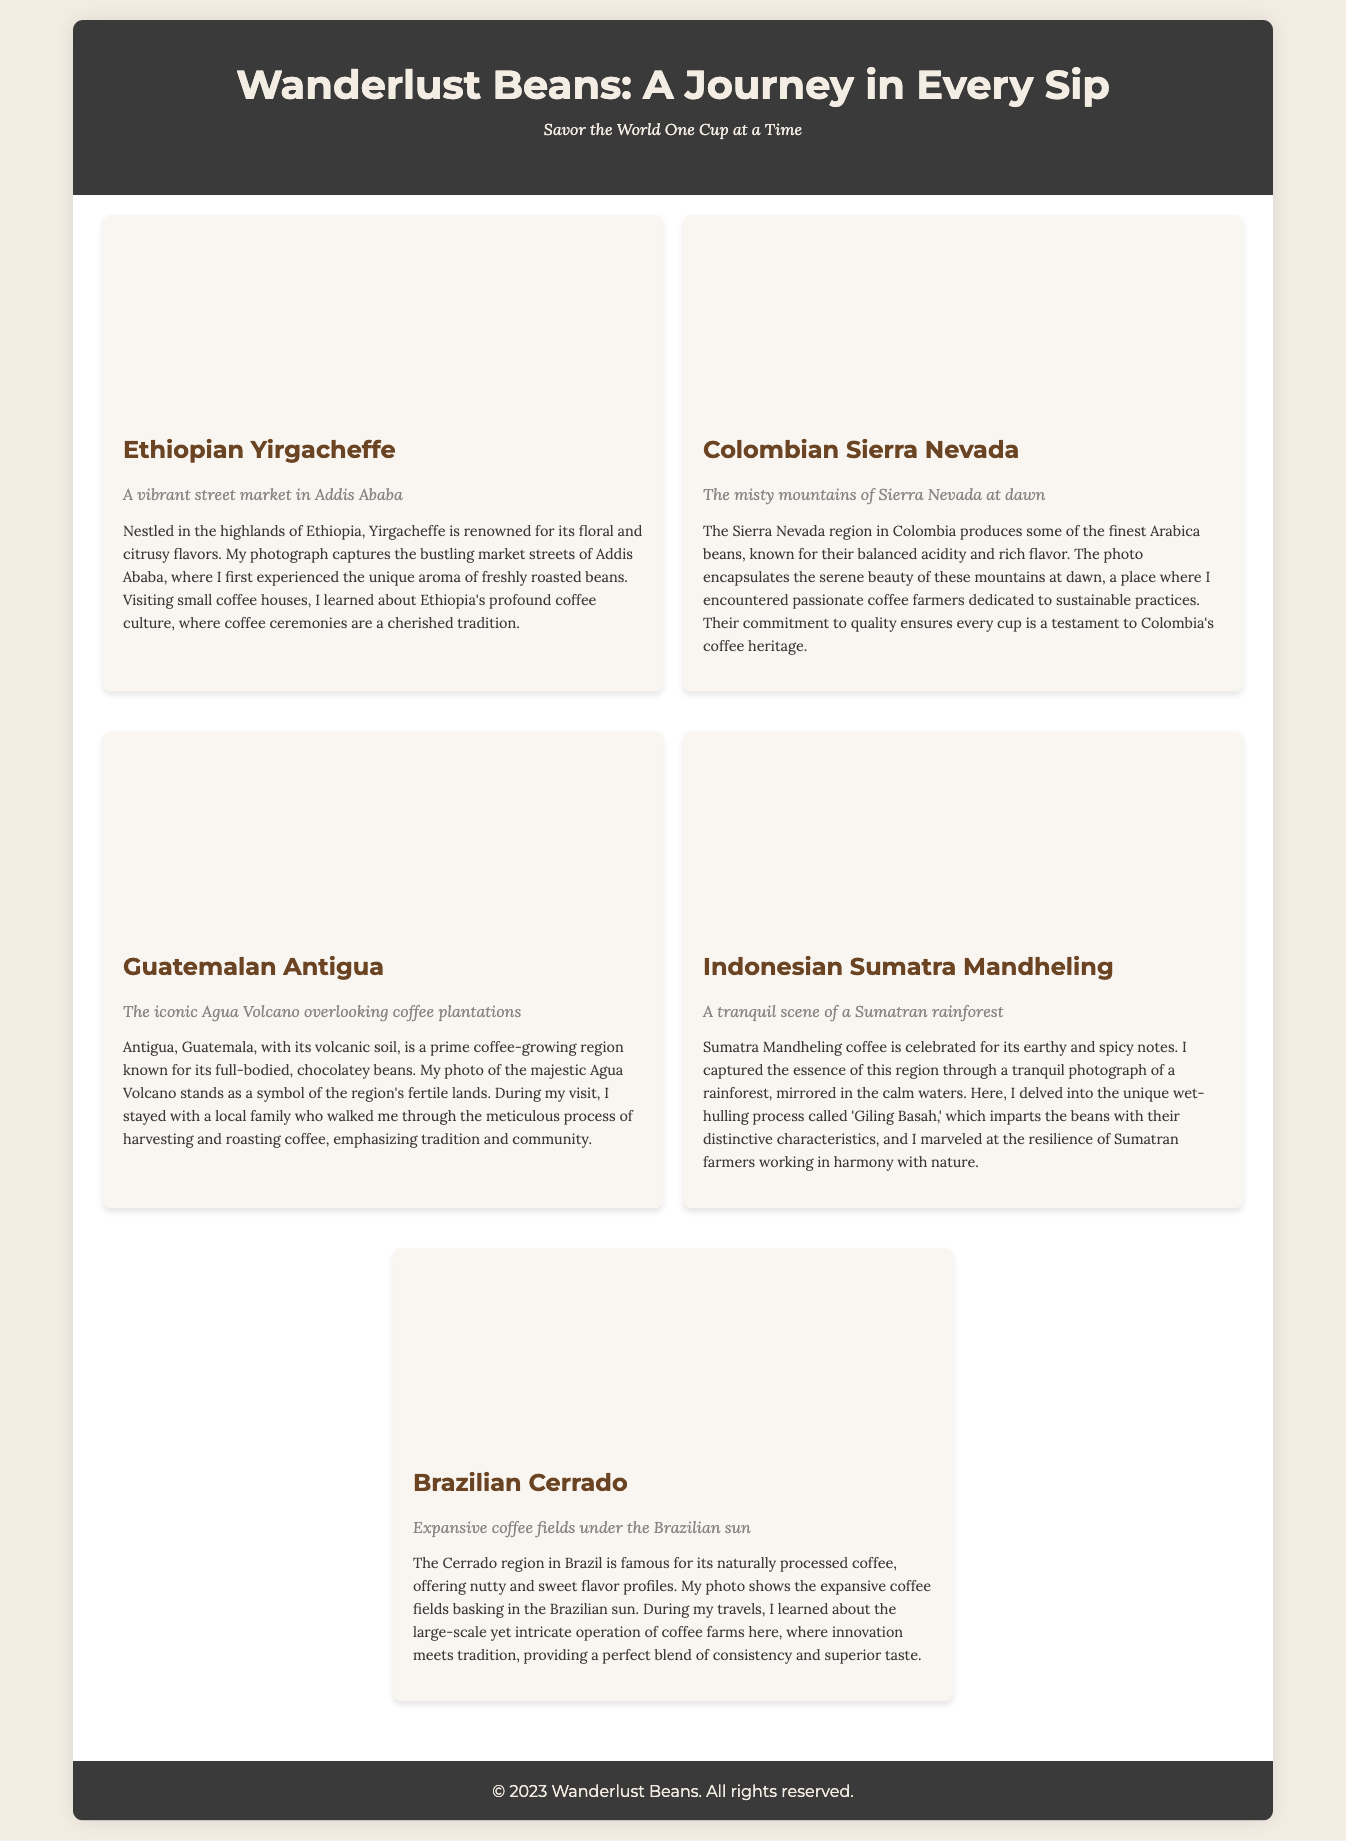What is the title of the collection? The title is prominently displayed at the top of the document and is "Wanderlust Beans: A Journey in Every Sip."
Answer: Wanderlust Beans: A Journey in Every Sip How many coffee types are featured? The document lists five distinct coffee types, each with its own story and image.
Answer: Five Which country is associated with Yirgacheffe coffee? The information provided in the document specifies Yirgacheffe coffee is from Ethiopia.
Answer: Ethiopia What flavor notes are described for the Colombian Sierra Nevada? The document describes the flavor notes of the Colombian Sierra Nevada coffee as "balanced acidity and rich flavor."
Answer: Balanced acidity and rich flavor What process infuses unique characteristics into Sumatran coffee? The document mentions the wet-hulling process called 'Giling Basah' as the technique imparting distinctive characteristics.
Answer: Giling Basah What natural feature is visible in the Guatemalan Antigua photo? The iconic Agua Volcano overlooks the coffee plantations in the Guatemalan Antigua photo.
Answer: Agua Volcano Which phrase describes the Brazilian Cerrado coffee? The document notes that it offers "nutty and sweet flavor profiles."
Answer: Nutty and sweet flavor profiles What visual style is used for the coffee images? The document indicates that the images are presented with a background size of "cover" and center positioning, enhancing their visual appeal.
Answer: Cover What kind of tradition is mentioned in relation to Ethiopian coffee culture? The document notes that coffee ceremonies are a cherished tradition in Ethiopian coffee culture.
Answer: Coffee ceremonies 